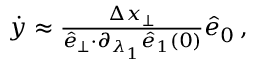Convert formula to latex. <formula><loc_0><loc_0><loc_500><loc_500>\begin{array} { r } { \dot { y } \approx \frac { \Delta x _ { \perp } } { \hat { e } _ { \perp } { \cdot } \partial _ { \lambda _ { 1 } } \hat { e } _ { 1 } ( 0 ) } \hat { e } _ { 0 } \, , } \end{array}</formula> 